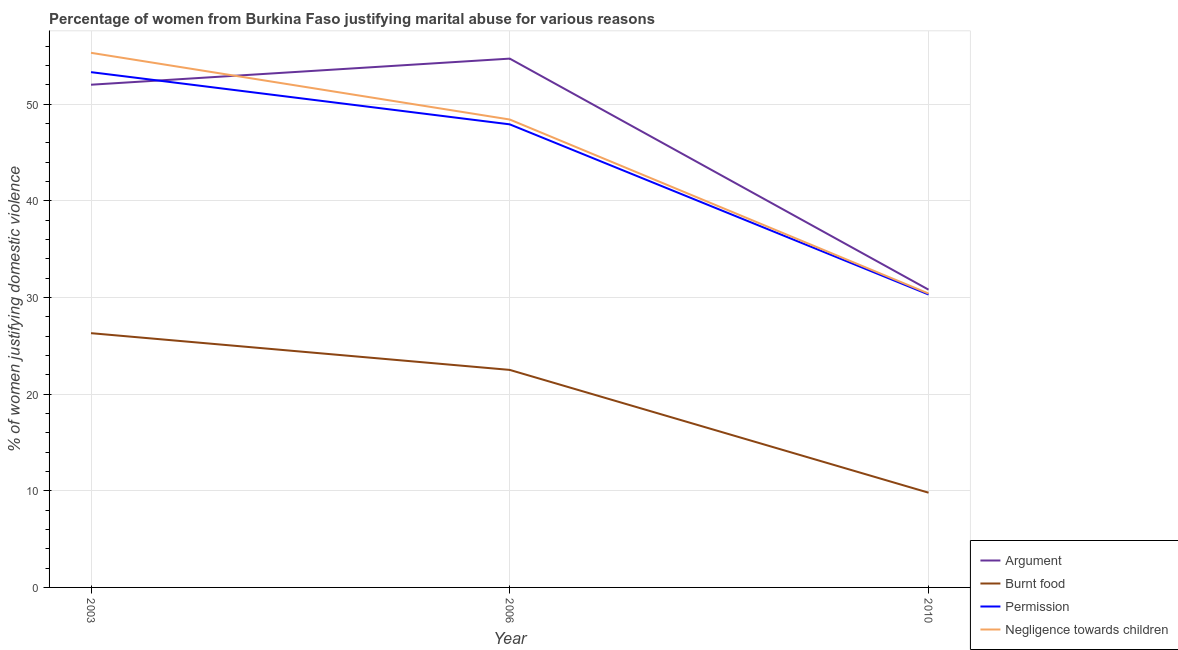How many different coloured lines are there?
Your answer should be compact. 4. Is the number of lines equal to the number of legend labels?
Provide a short and direct response. Yes. What is the percentage of women justifying abuse for going without permission in 2006?
Give a very brief answer. 47.9. Across all years, what is the maximum percentage of women justifying abuse for going without permission?
Provide a succinct answer. 53.3. Across all years, what is the minimum percentage of women justifying abuse in the case of an argument?
Ensure brevity in your answer.  30.8. What is the total percentage of women justifying abuse in the case of an argument in the graph?
Your answer should be very brief. 137.5. What is the difference between the percentage of women justifying abuse for going without permission in 2006 and that in 2010?
Give a very brief answer. 17.6. What is the difference between the percentage of women justifying abuse in the case of an argument in 2003 and the percentage of women justifying abuse for burning food in 2010?
Ensure brevity in your answer.  42.2. What is the average percentage of women justifying abuse in the case of an argument per year?
Ensure brevity in your answer.  45.83. In the year 2006, what is the difference between the percentage of women justifying abuse for burning food and percentage of women justifying abuse in the case of an argument?
Your answer should be compact. -32.2. In how many years, is the percentage of women justifying abuse for burning food greater than 32 %?
Offer a very short reply. 0. What is the ratio of the percentage of women justifying abuse in the case of an argument in 2003 to that in 2006?
Offer a terse response. 0.95. What is the difference between the highest and the second highest percentage of women justifying abuse in the case of an argument?
Give a very brief answer. 2.7. What is the difference between the highest and the lowest percentage of women justifying abuse for showing negligence towards children?
Provide a succinct answer. 24.9. Is it the case that in every year, the sum of the percentage of women justifying abuse in the case of an argument and percentage of women justifying abuse for burning food is greater than the percentage of women justifying abuse for going without permission?
Offer a very short reply. Yes. How many lines are there?
Give a very brief answer. 4. Are the values on the major ticks of Y-axis written in scientific E-notation?
Keep it short and to the point. No. Does the graph contain any zero values?
Offer a very short reply. No. Where does the legend appear in the graph?
Offer a terse response. Bottom right. What is the title of the graph?
Your answer should be compact. Percentage of women from Burkina Faso justifying marital abuse for various reasons. What is the label or title of the X-axis?
Keep it short and to the point. Year. What is the label or title of the Y-axis?
Give a very brief answer. % of women justifying domestic violence. What is the % of women justifying domestic violence of Argument in 2003?
Your response must be concise. 52. What is the % of women justifying domestic violence of Burnt food in 2003?
Your answer should be compact. 26.3. What is the % of women justifying domestic violence of Permission in 2003?
Provide a succinct answer. 53.3. What is the % of women justifying domestic violence of Negligence towards children in 2003?
Give a very brief answer. 55.3. What is the % of women justifying domestic violence of Argument in 2006?
Provide a short and direct response. 54.7. What is the % of women justifying domestic violence in Permission in 2006?
Your response must be concise. 47.9. What is the % of women justifying domestic violence of Negligence towards children in 2006?
Offer a very short reply. 48.4. What is the % of women justifying domestic violence in Argument in 2010?
Keep it short and to the point. 30.8. What is the % of women justifying domestic violence of Permission in 2010?
Make the answer very short. 30.3. What is the % of women justifying domestic violence in Negligence towards children in 2010?
Give a very brief answer. 30.4. Across all years, what is the maximum % of women justifying domestic violence in Argument?
Provide a short and direct response. 54.7. Across all years, what is the maximum % of women justifying domestic violence in Burnt food?
Make the answer very short. 26.3. Across all years, what is the maximum % of women justifying domestic violence in Permission?
Provide a short and direct response. 53.3. Across all years, what is the maximum % of women justifying domestic violence of Negligence towards children?
Your response must be concise. 55.3. Across all years, what is the minimum % of women justifying domestic violence in Argument?
Give a very brief answer. 30.8. Across all years, what is the minimum % of women justifying domestic violence in Burnt food?
Give a very brief answer. 9.8. Across all years, what is the minimum % of women justifying domestic violence in Permission?
Make the answer very short. 30.3. Across all years, what is the minimum % of women justifying domestic violence of Negligence towards children?
Offer a terse response. 30.4. What is the total % of women justifying domestic violence in Argument in the graph?
Offer a very short reply. 137.5. What is the total % of women justifying domestic violence in Burnt food in the graph?
Offer a terse response. 58.6. What is the total % of women justifying domestic violence in Permission in the graph?
Your answer should be very brief. 131.5. What is the total % of women justifying domestic violence of Negligence towards children in the graph?
Your answer should be very brief. 134.1. What is the difference between the % of women justifying domestic violence of Burnt food in 2003 and that in 2006?
Provide a short and direct response. 3.8. What is the difference between the % of women justifying domestic violence in Negligence towards children in 2003 and that in 2006?
Make the answer very short. 6.9. What is the difference between the % of women justifying domestic violence in Argument in 2003 and that in 2010?
Make the answer very short. 21.2. What is the difference between the % of women justifying domestic violence in Negligence towards children in 2003 and that in 2010?
Offer a very short reply. 24.9. What is the difference between the % of women justifying domestic violence in Argument in 2006 and that in 2010?
Make the answer very short. 23.9. What is the difference between the % of women justifying domestic violence of Argument in 2003 and the % of women justifying domestic violence of Burnt food in 2006?
Ensure brevity in your answer.  29.5. What is the difference between the % of women justifying domestic violence in Burnt food in 2003 and the % of women justifying domestic violence in Permission in 2006?
Provide a succinct answer. -21.6. What is the difference between the % of women justifying domestic violence in Burnt food in 2003 and the % of women justifying domestic violence in Negligence towards children in 2006?
Offer a terse response. -22.1. What is the difference between the % of women justifying domestic violence in Argument in 2003 and the % of women justifying domestic violence in Burnt food in 2010?
Your answer should be compact. 42.2. What is the difference between the % of women justifying domestic violence in Argument in 2003 and the % of women justifying domestic violence in Permission in 2010?
Your answer should be very brief. 21.7. What is the difference between the % of women justifying domestic violence in Argument in 2003 and the % of women justifying domestic violence in Negligence towards children in 2010?
Offer a terse response. 21.6. What is the difference between the % of women justifying domestic violence of Burnt food in 2003 and the % of women justifying domestic violence of Permission in 2010?
Provide a succinct answer. -4. What is the difference between the % of women justifying domestic violence in Permission in 2003 and the % of women justifying domestic violence in Negligence towards children in 2010?
Offer a very short reply. 22.9. What is the difference between the % of women justifying domestic violence in Argument in 2006 and the % of women justifying domestic violence in Burnt food in 2010?
Offer a terse response. 44.9. What is the difference between the % of women justifying domestic violence in Argument in 2006 and the % of women justifying domestic violence in Permission in 2010?
Offer a terse response. 24.4. What is the difference between the % of women justifying domestic violence in Argument in 2006 and the % of women justifying domestic violence in Negligence towards children in 2010?
Offer a terse response. 24.3. What is the difference between the % of women justifying domestic violence in Burnt food in 2006 and the % of women justifying domestic violence in Permission in 2010?
Ensure brevity in your answer.  -7.8. What is the difference between the % of women justifying domestic violence in Burnt food in 2006 and the % of women justifying domestic violence in Negligence towards children in 2010?
Give a very brief answer. -7.9. What is the difference between the % of women justifying domestic violence of Permission in 2006 and the % of women justifying domestic violence of Negligence towards children in 2010?
Your answer should be very brief. 17.5. What is the average % of women justifying domestic violence of Argument per year?
Ensure brevity in your answer.  45.83. What is the average % of women justifying domestic violence in Burnt food per year?
Ensure brevity in your answer.  19.53. What is the average % of women justifying domestic violence in Permission per year?
Make the answer very short. 43.83. What is the average % of women justifying domestic violence of Negligence towards children per year?
Provide a short and direct response. 44.7. In the year 2003, what is the difference between the % of women justifying domestic violence in Argument and % of women justifying domestic violence in Burnt food?
Give a very brief answer. 25.7. In the year 2003, what is the difference between the % of women justifying domestic violence of Argument and % of women justifying domestic violence of Negligence towards children?
Your answer should be compact. -3.3. In the year 2003, what is the difference between the % of women justifying domestic violence of Burnt food and % of women justifying domestic violence of Negligence towards children?
Your response must be concise. -29. In the year 2003, what is the difference between the % of women justifying domestic violence in Permission and % of women justifying domestic violence in Negligence towards children?
Make the answer very short. -2. In the year 2006, what is the difference between the % of women justifying domestic violence of Argument and % of women justifying domestic violence of Burnt food?
Keep it short and to the point. 32.2. In the year 2006, what is the difference between the % of women justifying domestic violence in Argument and % of women justifying domestic violence in Permission?
Ensure brevity in your answer.  6.8. In the year 2006, what is the difference between the % of women justifying domestic violence of Argument and % of women justifying domestic violence of Negligence towards children?
Your answer should be very brief. 6.3. In the year 2006, what is the difference between the % of women justifying domestic violence in Burnt food and % of women justifying domestic violence in Permission?
Your answer should be very brief. -25.4. In the year 2006, what is the difference between the % of women justifying domestic violence of Burnt food and % of women justifying domestic violence of Negligence towards children?
Ensure brevity in your answer.  -25.9. In the year 2006, what is the difference between the % of women justifying domestic violence of Permission and % of women justifying domestic violence of Negligence towards children?
Your answer should be very brief. -0.5. In the year 2010, what is the difference between the % of women justifying domestic violence of Argument and % of women justifying domestic violence of Burnt food?
Keep it short and to the point. 21. In the year 2010, what is the difference between the % of women justifying domestic violence of Argument and % of women justifying domestic violence of Permission?
Offer a very short reply. 0.5. In the year 2010, what is the difference between the % of women justifying domestic violence of Argument and % of women justifying domestic violence of Negligence towards children?
Your answer should be compact. 0.4. In the year 2010, what is the difference between the % of women justifying domestic violence of Burnt food and % of women justifying domestic violence of Permission?
Offer a very short reply. -20.5. In the year 2010, what is the difference between the % of women justifying domestic violence of Burnt food and % of women justifying domestic violence of Negligence towards children?
Your answer should be compact. -20.6. What is the ratio of the % of women justifying domestic violence of Argument in 2003 to that in 2006?
Your answer should be very brief. 0.95. What is the ratio of the % of women justifying domestic violence of Burnt food in 2003 to that in 2006?
Give a very brief answer. 1.17. What is the ratio of the % of women justifying domestic violence of Permission in 2003 to that in 2006?
Offer a terse response. 1.11. What is the ratio of the % of women justifying domestic violence in Negligence towards children in 2003 to that in 2006?
Give a very brief answer. 1.14. What is the ratio of the % of women justifying domestic violence of Argument in 2003 to that in 2010?
Give a very brief answer. 1.69. What is the ratio of the % of women justifying domestic violence of Burnt food in 2003 to that in 2010?
Provide a succinct answer. 2.68. What is the ratio of the % of women justifying domestic violence in Permission in 2003 to that in 2010?
Provide a succinct answer. 1.76. What is the ratio of the % of women justifying domestic violence in Negligence towards children in 2003 to that in 2010?
Offer a very short reply. 1.82. What is the ratio of the % of women justifying domestic violence of Argument in 2006 to that in 2010?
Provide a short and direct response. 1.78. What is the ratio of the % of women justifying domestic violence in Burnt food in 2006 to that in 2010?
Your answer should be compact. 2.3. What is the ratio of the % of women justifying domestic violence of Permission in 2006 to that in 2010?
Make the answer very short. 1.58. What is the ratio of the % of women justifying domestic violence of Negligence towards children in 2006 to that in 2010?
Make the answer very short. 1.59. What is the difference between the highest and the second highest % of women justifying domestic violence in Argument?
Ensure brevity in your answer.  2.7. What is the difference between the highest and the second highest % of women justifying domestic violence of Burnt food?
Ensure brevity in your answer.  3.8. What is the difference between the highest and the second highest % of women justifying domestic violence of Negligence towards children?
Provide a short and direct response. 6.9. What is the difference between the highest and the lowest % of women justifying domestic violence of Argument?
Make the answer very short. 23.9. What is the difference between the highest and the lowest % of women justifying domestic violence in Burnt food?
Offer a very short reply. 16.5. What is the difference between the highest and the lowest % of women justifying domestic violence in Permission?
Keep it short and to the point. 23. What is the difference between the highest and the lowest % of women justifying domestic violence of Negligence towards children?
Ensure brevity in your answer.  24.9. 